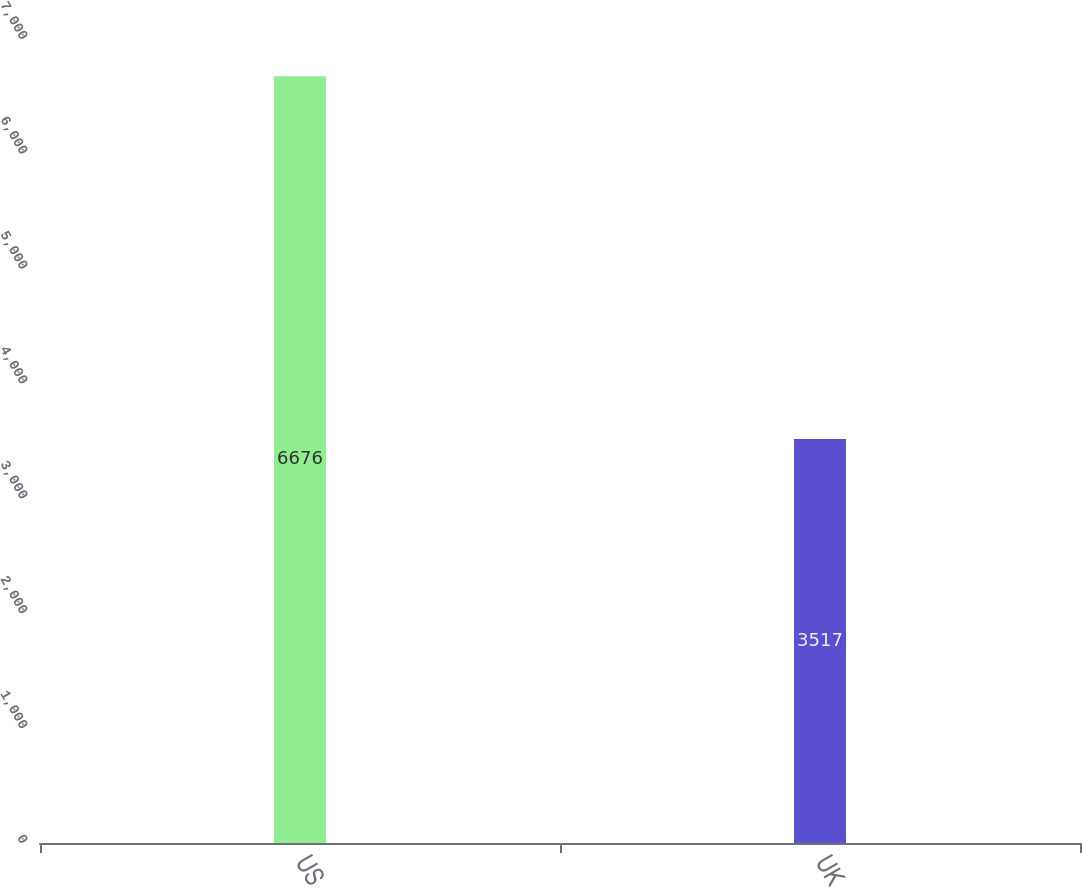Convert chart. <chart><loc_0><loc_0><loc_500><loc_500><bar_chart><fcel>US<fcel>UK<nl><fcel>6676<fcel>3517<nl></chart> 